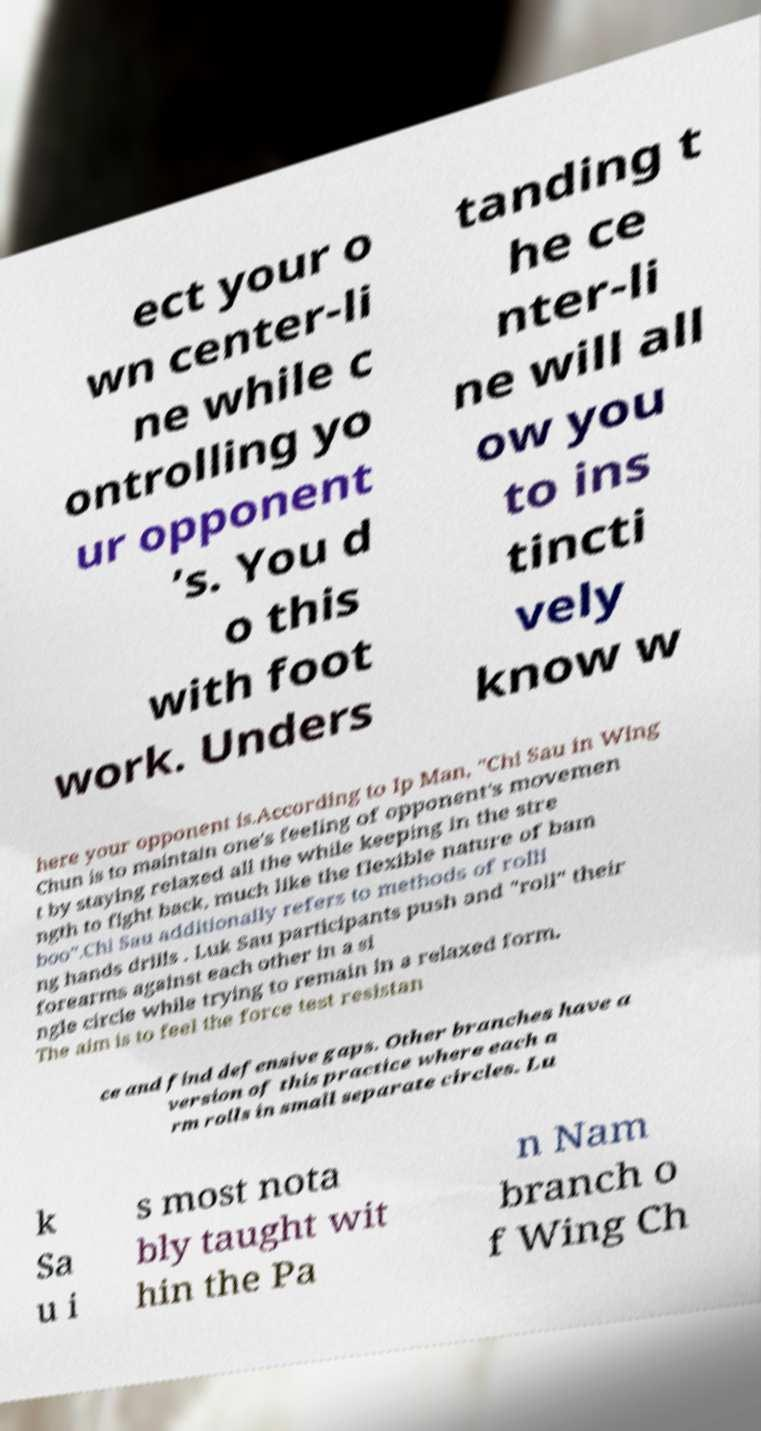Could you extract and type out the text from this image? ect your o wn center-li ne while c ontrolling yo ur opponent ’s. You d o this with foot work. Unders tanding t he ce nter-li ne will all ow you to ins tincti vely know w here your opponent is.According to Ip Man, "Chi Sau in Wing Chun is to maintain one's feeling of opponent's movemen t by staying relaxed all the while keeping in the stre ngth to fight back, much like the flexible nature of bam boo".Chi Sau additionally refers to methods of rolli ng hands drills . Luk Sau participants push and "roll" their forearms against each other in a si ngle circle while trying to remain in a relaxed form. The aim is to feel the force test resistan ce and find defensive gaps. Other branches have a version of this practice where each a rm rolls in small separate circles. Lu k Sa u i s most nota bly taught wit hin the Pa n Nam branch o f Wing Ch 